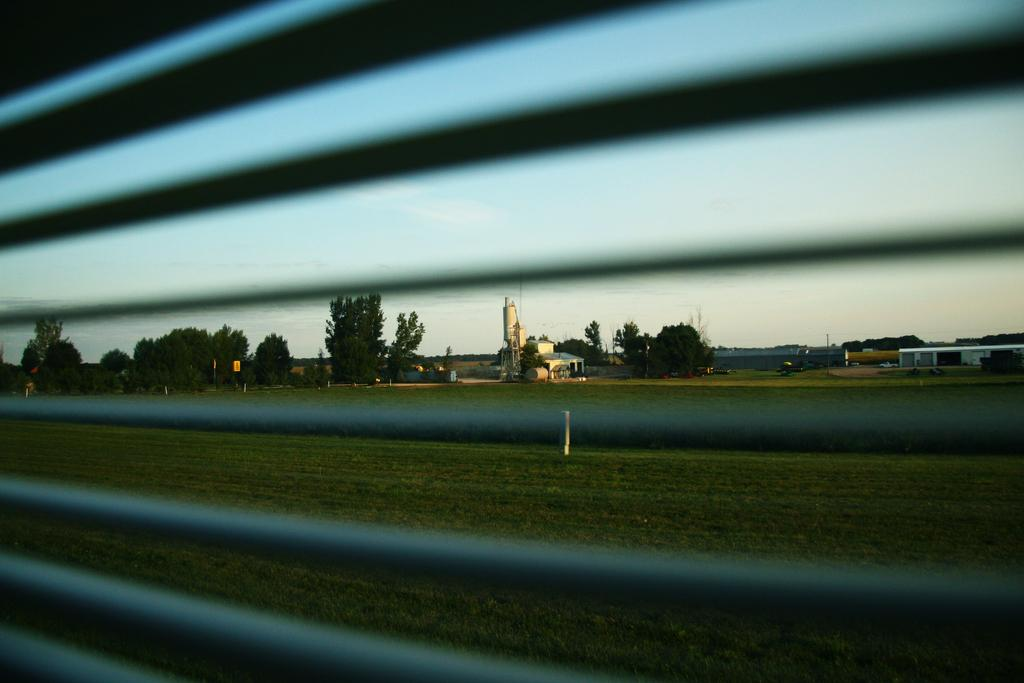What is the perspective of the image? The image is taken from a vehicle. What can be seen through the window in the image? There is a window visible in the image, and through it, grass, trees, buildings, and the sky can be seen. What type of vegetation is present in the image? There is grass and trees in the image. What type of structures are present in the image? There are buildings in the image. What is visible in the background of the image? The sky is visible in the background of the image. How many mountains can be seen in the image? There are no mountains visible in the image. What type of order is being followed by the trees in the image? The trees in the image are not following any specific order; they are randomly distributed. 